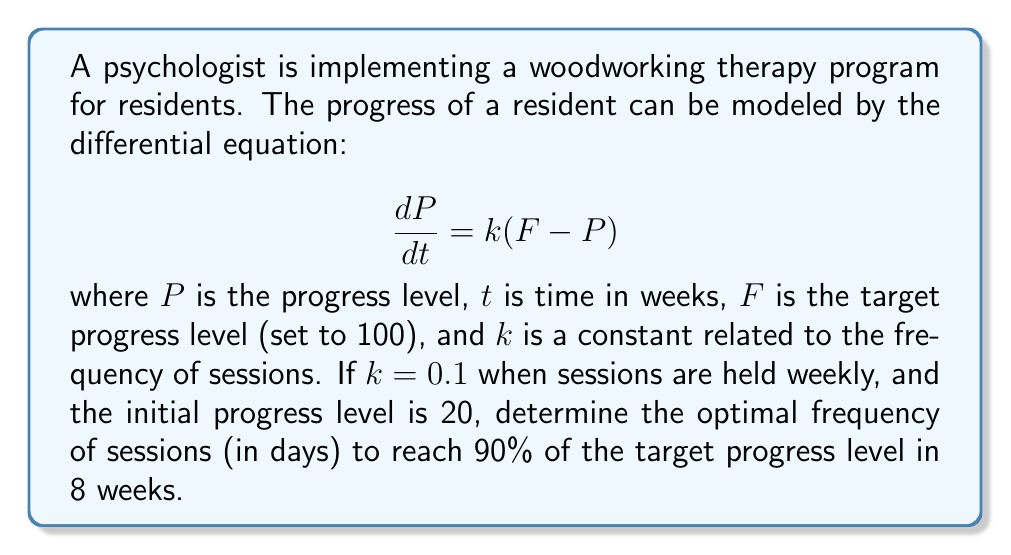Give your solution to this math problem. 1) First, we need to solve the differential equation. The general solution is:

   $$P(t) = F + (P_0 - F)e^{-kt}$$

   where $P_0$ is the initial progress level.

2) Substitute the given values: $F = 100$, $P_0 = 20$, and we want $P(8) = 0.9F = 90$:

   $$90 = 100 + (20 - 100)e^{-8k}$$

3) Simplify:
   
   $$-10 = -80e^{-8k}$$
   $$\frac{1}{8} = e^{-8k}$$

4) Take natural log of both sides:

   $$\ln(\frac{1}{8}) = -8k$$
   $$-\ln(8) = -8k$$

5) Solve for $k$:

   $$k = \frac{\ln(8)}{8} \approx 0.2599$$

6) We know that $k = 0.1$ for weekly sessions. To find the optimal frequency in days:

   $$\frac{0.2599}{0.1} \cdot 7 \text{ days} \approx 18.19 \text{ days}$$

7) Round to the nearest whole number of days:

   Optimal frequency ≈ 18 days
Answer: 18 days 